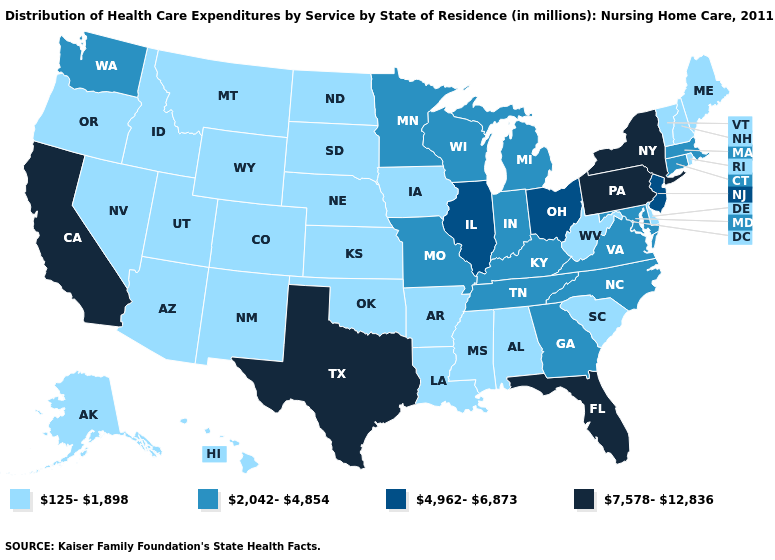Does Kentucky have the lowest value in the South?
Answer briefly. No. Which states have the lowest value in the USA?
Quick response, please. Alabama, Alaska, Arizona, Arkansas, Colorado, Delaware, Hawaii, Idaho, Iowa, Kansas, Louisiana, Maine, Mississippi, Montana, Nebraska, Nevada, New Hampshire, New Mexico, North Dakota, Oklahoma, Oregon, Rhode Island, South Carolina, South Dakota, Utah, Vermont, West Virginia, Wyoming. Does Ohio have the lowest value in the MidWest?
Answer briefly. No. What is the value of Minnesota?
Write a very short answer. 2,042-4,854. Does Wisconsin have the lowest value in the USA?
Write a very short answer. No. What is the value of Wisconsin?
Write a very short answer. 2,042-4,854. What is the value of Maine?
Answer briefly. 125-1,898. What is the value of Michigan?
Concise answer only. 2,042-4,854. Name the states that have a value in the range 2,042-4,854?
Be succinct. Connecticut, Georgia, Indiana, Kentucky, Maryland, Massachusetts, Michigan, Minnesota, Missouri, North Carolina, Tennessee, Virginia, Washington, Wisconsin. What is the value of Connecticut?
Short answer required. 2,042-4,854. Name the states that have a value in the range 4,962-6,873?
Be succinct. Illinois, New Jersey, Ohio. Name the states that have a value in the range 125-1,898?
Give a very brief answer. Alabama, Alaska, Arizona, Arkansas, Colorado, Delaware, Hawaii, Idaho, Iowa, Kansas, Louisiana, Maine, Mississippi, Montana, Nebraska, Nevada, New Hampshire, New Mexico, North Dakota, Oklahoma, Oregon, Rhode Island, South Carolina, South Dakota, Utah, Vermont, West Virginia, Wyoming. Among the states that border North Carolina , which have the highest value?
Keep it brief. Georgia, Tennessee, Virginia. Name the states that have a value in the range 7,578-12,836?
Concise answer only. California, Florida, New York, Pennsylvania, Texas. What is the lowest value in the USA?
Short answer required. 125-1,898. 